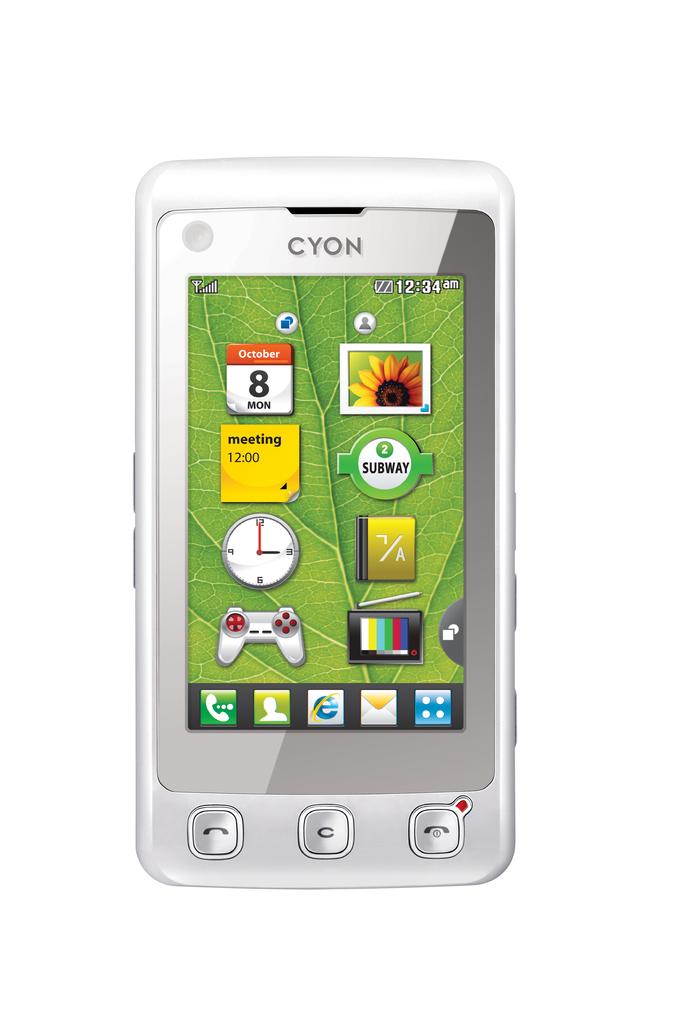What time is the meeting, according to the yellow sticky note?
Provide a succinct answer. 12:00. 